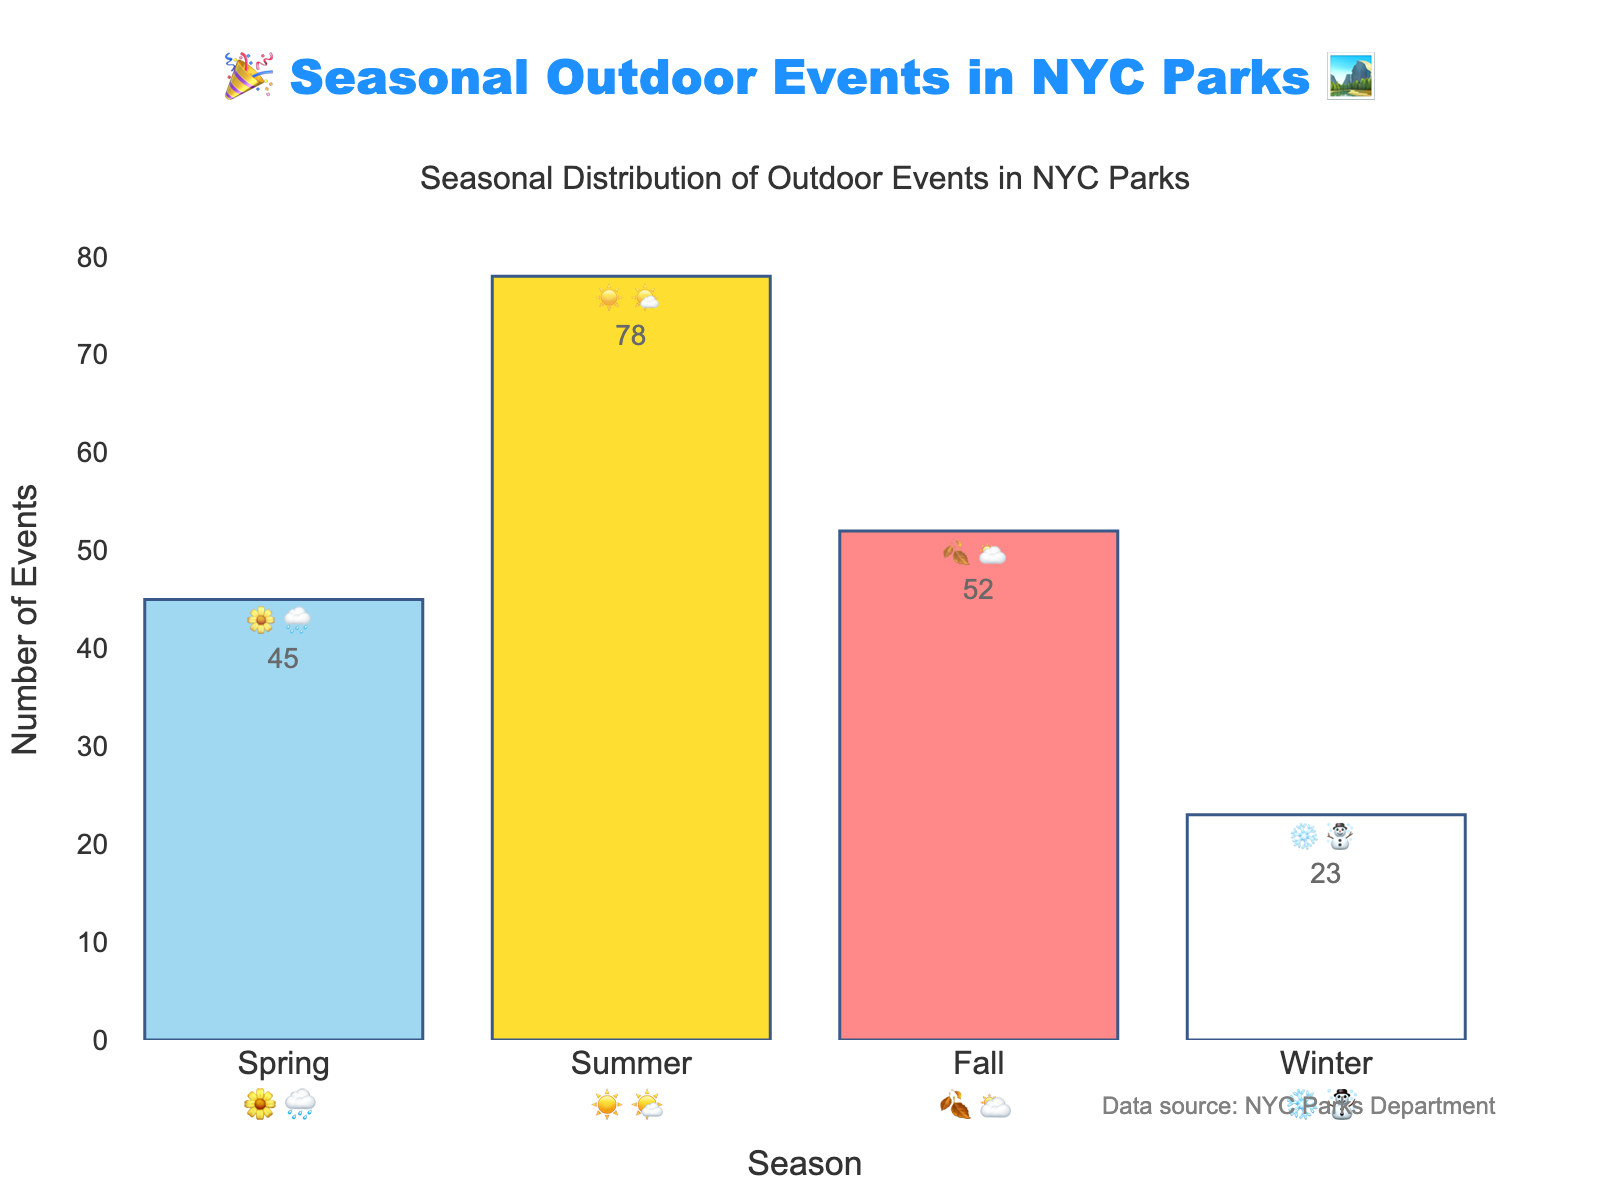What's the highest number of outdoor events in a season? The figure shows the number of events per season. By observing the height of the bars, we see that Summer has the highest bar with 78 events.
Answer: 78 In which season do the parks host the least number of outdoor events? Winter has the shortest bar, indicating the least number of events at 23.
Answer: Winter What's the total number of outdoor events for all seasons combined? Add the number of events from all seasons: 45 (Spring) + 78 (Summer) + 52 (Fall) + 23 (Winter) = 198.
Answer: 198 How many more events are there in Summer compared to Winter? Subtract the number of Winter events from the number of Summer events: 78 (Summer) - 23 (Winter) = 55.
Answer: 55 What's the average number of events per season? Add the number of events for all seasons and divide by 4: (45 + 78 + 52 + 23) / 4 = 198 / 4 = 49.5.
Answer: 49.5 Which season's description includes emojis 🌼 and 🌧️? Observe the text labels: Spring is described with 🌼 and 🌧️.
Answer: Spring Is the number of events in Spring more or less than half the events in Summer? Half of the Summer events is 78 / 2 = 39. Since Spring has 45 events, which is more than 39, Spring has more than half the events of Summer.
Answer: More Compare the number of events in Fall to Spring. Which has more? The bar for Fall represents 52 events, while Spring has 45. Since 52 is greater than 45, Fall has more events.
Answer: Fall Is the number of events in Spring closer to the number of events in Winter or Fall? Calculate the differences: Spring to Winter is 45 - 23 = 22, Spring to Fall is 52 - 45 = 7. Since 7 is less than 22, Spring is closer to Fall.
Answer: Fall What is the emoji representation for the season with the most outdoor events? Summer has the most events and its weather emojis are ☀️ and 🌤️.
Answer: ☀️🌤️ 